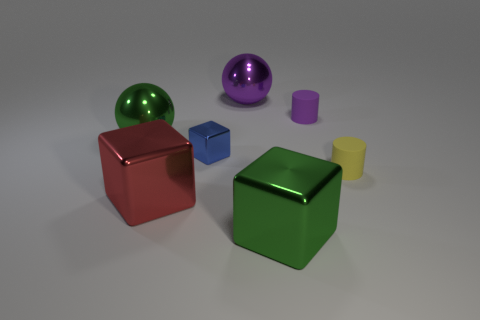The big purple object has what shape?
Your answer should be compact. Sphere. There is a green thing on the right side of the blue metal block that is on the left side of the big green thing in front of the red shiny block; what size is it?
Ensure brevity in your answer.  Large. What number of other objects are there of the same shape as the blue shiny thing?
Make the answer very short. 2. Do the green thing behind the tiny yellow thing and the big purple object behind the yellow thing have the same shape?
Offer a very short reply. Yes. How many cylinders are either rubber objects or blue objects?
Keep it short and to the point. 2. There is a large sphere that is on the right side of the large cube on the left side of the green object in front of the blue shiny cube; what is it made of?
Give a very brief answer. Metal. How many other objects are there of the same size as the green ball?
Your response must be concise. 3. Are there more big green metal spheres that are behind the red shiny cube than red spheres?
Ensure brevity in your answer.  Yes. The rubber cylinder that is the same size as the yellow matte thing is what color?
Offer a terse response. Purple. There is a green object on the left side of the blue metal object; what number of red metallic cubes are behind it?
Your answer should be very brief. 0. 